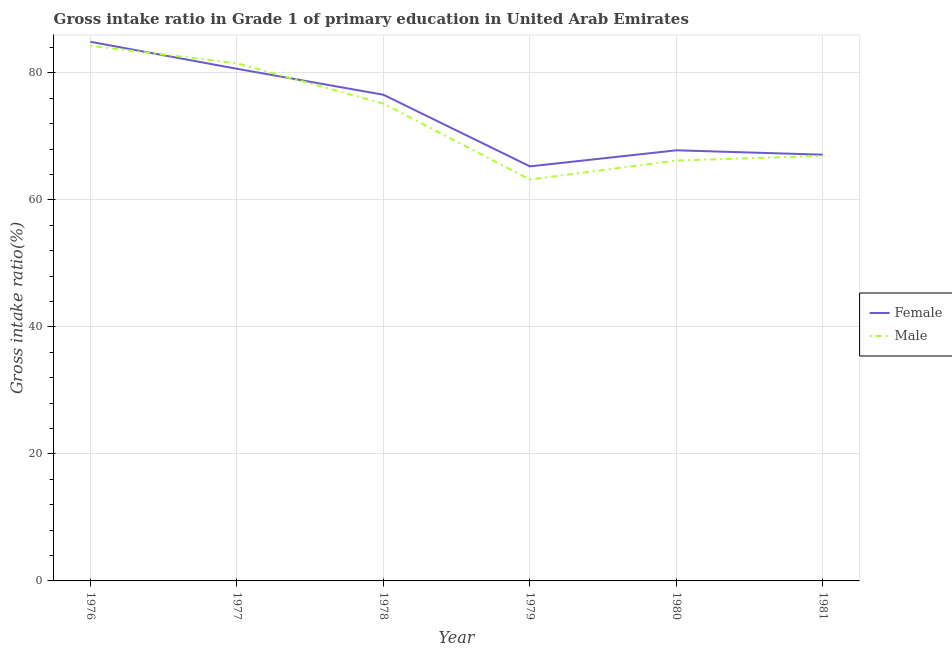How many different coloured lines are there?
Offer a very short reply. 2. Does the line corresponding to gross intake ratio(male) intersect with the line corresponding to gross intake ratio(female)?
Your answer should be compact. Yes. What is the gross intake ratio(female) in 1977?
Your response must be concise. 80.64. Across all years, what is the maximum gross intake ratio(female)?
Ensure brevity in your answer.  84.89. Across all years, what is the minimum gross intake ratio(male)?
Ensure brevity in your answer.  63.2. In which year was the gross intake ratio(female) maximum?
Keep it short and to the point. 1976. In which year was the gross intake ratio(male) minimum?
Your answer should be very brief. 1979. What is the total gross intake ratio(female) in the graph?
Your response must be concise. 442.26. What is the difference between the gross intake ratio(female) in 1979 and that in 1981?
Make the answer very short. -1.84. What is the difference between the gross intake ratio(female) in 1978 and the gross intake ratio(male) in 1977?
Make the answer very short. -4.95. What is the average gross intake ratio(male) per year?
Provide a short and direct response. 72.87. In the year 1976, what is the difference between the gross intake ratio(female) and gross intake ratio(male)?
Your answer should be very brief. 0.64. What is the ratio of the gross intake ratio(female) in 1980 to that in 1981?
Your response must be concise. 1.01. Is the difference between the gross intake ratio(male) in 1980 and 1981 greater than the difference between the gross intake ratio(female) in 1980 and 1981?
Make the answer very short. No. What is the difference between the highest and the second highest gross intake ratio(male)?
Your response must be concise. 2.74. What is the difference between the highest and the lowest gross intake ratio(female)?
Your response must be concise. 19.62. In how many years, is the gross intake ratio(male) greater than the average gross intake ratio(male) taken over all years?
Your answer should be very brief. 3. Is the sum of the gross intake ratio(female) in 1976 and 1980 greater than the maximum gross intake ratio(male) across all years?
Your response must be concise. Yes. Does the gross intake ratio(male) monotonically increase over the years?
Make the answer very short. No. How many years are there in the graph?
Give a very brief answer. 6. What is the difference between two consecutive major ticks on the Y-axis?
Offer a terse response. 20. Are the values on the major ticks of Y-axis written in scientific E-notation?
Provide a succinct answer. No. Does the graph contain any zero values?
Provide a short and direct response. No. Where does the legend appear in the graph?
Your answer should be compact. Center right. How are the legend labels stacked?
Provide a short and direct response. Vertical. What is the title of the graph?
Your answer should be very brief. Gross intake ratio in Grade 1 of primary education in United Arab Emirates. Does "Study and work" appear as one of the legend labels in the graph?
Your answer should be compact. No. What is the label or title of the X-axis?
Keep it short and to the point. Year. What is the label or title of the Y-axis?
Offer a terse response. Gross intake ratio(%). What is the Gross intake ratio(%) of Female in 1976?
Provide a succinct answer. 84.89. What is the Gross intake ratio(%) of Male in 1976?
Offer a terse response. 84.25. What is the Gross intake ratio(%) in Female in 1977?
Provide a short and direct response. 80.64. What is the Gross intake ratio(%) of Male in 1977?
Keep it short and to the point. 81.51. What is the Gross intake ratio(%) of Female in 1978?
Ensure brevity in your answer.  76.55. What is the Gross intake ratio(%) in Male in 1978?
Provide a short and direct response. 75.15. What is the Gross intake ratio(%) in Female in 1979?
Offer a terse response. 65.27. What is the Gross intake ratio(%) of Male in 1979?
Give a very brief answer. 63.2. What is the Gross intake ratio(%) of Female in 1980?
Make the answer very short. 67.8. What is the Gross intake ratio(%) in Male in 1980?
Offer a terse response. 66.19. What is the Gross intake ratio(%) in Female in 1981?
Offer a terse response. 67.11. What is the Gross intake ratio(%) of Male in 1981?
Offer a terse response. 66.92. Across all years, what is the maximum Gross intake ratio(%) in Female?
Your answer should be very brief. 84.89. Across all years, what is the maximum Gross intake ratio(%) in Male?
Offer a very short reply. 84.25. Across all years, what is the minimum Gross intake ratio(%) of Female?
Keep it short and to the point. 65.27. Across all years, what is the minimum Gross intake ratio(%) of Male?
Provide a short and direct response. 63.2. What is the total Gross intake ratio(%) of Female in the graph?
Ensure brevity in your answer.  442.26. What is the total Gross intake ratio(%) of Male in the graph?
Offer a terse response. 437.22. What is the difference between the Gross intake ratio(%) of Female in 1976 and that in 1977?
Your answer should be compact. 4.25. What is the difference between the Gross intake ratio(%) of Male in 1976 and that in 1977?
Keep it short and to the point. 2.74. What is the difference between the Gross intake ratio(%) of Female in 1976 and that in 1978?
Offer a terse response. 8.34. What is the difference between the Gross intake ratio(%) of Male in 1976 and that in 1978?
Provide a succinct answer. 9.1. What is the difference between the Gross intake ratio(%) of Female in 1976 and that in 1979?
Your answer should be compact. 19.62. What is the difference between the Gross intake ratio(%) in Male in 1976 and that in 1979?
Keep it short and to the point. 21.05. What is the difference between the Gross intake ratio(%) in Female in 1976 and that in 1980?
Make the answer very short. 17.09. What is the difference between the Gross intake ratio(%) in Male in 1976 and that in 1980?
Make the answer very short. 18.06. What is the difference between the Gross intake ratio(%) in Female in 1976 and that in 1981?
Ensure brevity in your answer.  17.78. What is the difference between the Gross intake ratio(%) of Male in 1976 and that in 1981?
Give a very brief answer. 17.33. What is the difference between the Gross intake ratio(%) of Female in 1977 and that in 1978?
Keep it short and to the point. 4.09. What is the difference between the Gross intake ratio(%) in Male in 1977 and that in 1978?
Give a very brief answer. 6.35. What is the difference between the Gross intake ratio(%) in Female in 1977 and that in 1979?
Ensure brevity in your answer.  15.37. What is the difference between the Gross intake ratio(%) in Male in 1977 and that in 1979?
Provide a short and direct response. 18.31. What is the difference between the Gross intake ratio(%) in Female in 1977 and that in 1980?
Offer a very short reply. 12.84. What is the difference between the Gross intake ratio(%) in Male in 1977 and that in 1980?
Ensure brevity in your answer.  15.32. What is the difference between the Gross intake ratio(%) of Female in 1977 and that in 1981?
Provide a short and direct response. 13.53. What is the difference between the Gross intake ratio(%) in Male in 1977 and that in 1981?
Provide a short and direct response. 14.58. What is the difference between the Gross intake ratio(%) of Female in 1978 and that in 1979?
Your answer should be very brief. 11.28. What is the difference between the Gross intake ratio(%) of Male in 1978 and that in 1979?
Your answer should be very brief. 11.95. What is the difference between the Gross intake ratio(%) in Female in 1978 and that in 1980?
Offer a terse response. 8.75. What is the difference between the Gross intake ratio(%) of Male in 1978 and that in 1980?
Keep it short and to the point. 8.96. What is the difference between the Gross intake ratio(%) in Female in 1978 and that in 1981?
Your answer should be compact. 9.44. What is the difference between the Gross intake ratio(%) of Male in 1978 and that in 1981?
Your answer should be compact. 8.23. What is the difference between the Gross intake ratio(%) in Female in 1979 and that in 1980?
Provide a short and direct response. -2.53. What is the difference between the Gross intake ratio(%) in Male in 1979 and that in 1980?
Your answer should be compact. -2.99. What is the difference between the Gross intake ratio(%) in Female in 1979 and that in 1981?
Your response must be concise. -1.84. What is the difference between the Gross intake ratio(%) of Male in 1979 and that in 1981?
Provide a short and direct response. -3.72. What is the difference between the Gross intake ratio(%) in Female in 1980 and that in 1981?
Your answer should be compact. 0.69. What is the difference between the Gross intake ratio(%) in Male in 1980 and that in 1981?
Your response must be concise. -0.73. What is the difference between the Gross intake ratio(%) in Female in 1976 and the Gross intake ratio(%) in Male in 1977?
Keep it short and to the point. 3.39. What is the difference between the Gross intake ratio(%) of Female in 1976 and the Gross intake ratio(%) of Male in 1978?
Your answer should be very brief. 9.74. What is the difference between the Gross intake ratio(%) of Female in 1976 and the Gross intake ratio(%) of Male in 1979?
Make the answer very short. 21.69. What is the difference between the Gross intake ratio(%) in Female in 1976 and the Gross intake ratio(%) in Male in 1980?
Give a very brief answer. 18.7. What is the difference between the Gross intake ratio(%) of Female in 1976 and the Gross intake ratio(%) of Male in 1981?
Give a very brief answer. 17.97. What is the difference between the Gross intake ratio(%) in Female in 1977 and the Gross intake ratio(%) in Male in 1978?
Your response must be concise. 5.48. What is the difference between the Gross intake ratio(%) in Female in 1977 and the Gross intake ratio(%) in Male in 1979?
Provide a short and direct response. 17.44. What is the difference between the Gross intake ratio(%) in Female in 1977 and the Gross intake ratio(%) in Male in 1980?
Keep it short and to the point. 14.45. What is the difference between the Gross intake ratio(%) of Female in 1977 and the Gross intake ratio(%) of Male in 1981?
Give a very brief answer. 13.71. What is the difference between the Gross intake ratio(%) of Female in 1978 and the Gross intake ratio(%) of Male in 1979?
Your response must be concise. 13.35. What is the difference between the Gross intake ratio(%) of Female in 1978 and the Gross intake ratio(%) of Male in 1980?
Provide a short and direct response. 10.36. What is the difference between the Gross intake ratio(%) of Female in 1978 and the Gross intake ratio(%) of Male in 1981?
Offer a very short reply. 9.63. What is the difference between the Gross intake ratio(%) in Female in 1979 and the Gross intake ratio(%) in Male in 1980?
Keep it short and to the point. -0.92. What is the difference between the Gross intake ratio(%) in Female in 1979 and the Gross intake ratio(%) in Male in 1981?
Keep it short and to the point. -1.65. What is the difference between the Gross intake ratio(%) in Female in 1980 and the Gross intake ratio(%) in Male in 1981?
Offer a very short reply. 0.88. What is the average Gross intake ratio(%) of Female per year?
Ensure brevity in your answer.  73.71. What is the average Gross intake ratio(%) of Male per year?
Give a very brief answer. 72.87. In the year 1976, what is the difference between the Gross intake ratio(%) in Female and Gross intake ratio(%) in Male?
Your answer should be very brief. 0.64. In the year 1977, what is the difference between the Gross intake ratio(%) of Female and Gross intake ratio(%) of Male?
Offer a terse response. -0.87. In the year 1978, what is the difference between the Gross intake ratio(%) in Female and Gross intake ratio(%) in Male?
Offer a terse response. 1.4. In the year 1979, what is the difference between the Gross intake ratio(%) in Female and Gross intake ratio(%) in Male?
Your answer should be very brief. 2.07. In the year 1980, what is the difference between the Gross intake ratio(%) of Female and Gross intake ratio(%) of Male?
Give a very brief answer. 1.61. In the year 1981, what is the difference between the Gross intake ratio(%) of Female and Gross intake ratio(%) of Male?
Ensure brevity in your answer.  0.19. What is the ratio of the Gross intake ratio(%) of Female in 1976 to that in 1977?
Offer a terse response. 1.05. What is the ratio of the Gross intake ratio(%) of Male in 1976 to that in 1977?
Ensure brevity in your answer.  1.03. What is the ratio of the Gross intake ratio(%) of Female in 1976 to that in 1978?
Give a very brief answer. 1.11. What is the ratio of the Gross intake ratio(%) of Male in 1976 to that in 1978?
Give a very brief answer. 1.12. What is the ratio of the Gross intake ratio(%) of Female in 1976 to that in 1979?
Your answer should be compact. 1.3. What is the ratio of the Gross intake ratio(%) in Male in 1976 to that in 1979?
Your answer should be compact. 1.33. What is the ratio of the Gross intake ratio(%) in Female in 1976 to that in 1980?
Your answer should be compact. 1.25. What is the ratio of the Gross intake ratio(%) in Male in 1976 to that in 1980?
Offer a very short reply. 1.27. What is the ratio of the Gross intake ratio(%) in Female in 1976 to that in 1981?
Give a very brief answer. 1.26. What is the ratio of the Gross intake ratio(%) in Male in 1976 to that in 1981?
Offer a terse response. 1.26. What is the ratio of the Gross intake ratio(%) in Female in 1977 to that in 1978?
Your answer should be very brief. 1.05. What is the ratio of the Gross intake ratio(%) of Male in 1977 to that in 1978?
Give a very brief answer. 1.08. What is the ratio of the Gross intake ratio(%) of Female in 1977 to that in 1979?
Keep it short and to the point. 1.24. What is the ratio of the Gross intake ratio(%) in Male in 1977 to that in 1979?
Your response must be concise. 1.29. What is the ratio of the Gross intake ratio(%) of Female in 1977 to that in 1980?
Give a very brief answer. 1.19. What is the ratio of the Gross intake ratio(%) in Male in 1977 to that in 1980?
Your answer should be very brief. 1.23. What is the ratio of the Gross intake ratio(%) in Female in 1977 to that in 1981?
Your answer should be very brief. 1.2. What is the ratio of the Gross intake ratio(%) of Male in 1977 to that in 1981?
Your response must be concise. 1.22. What is the ratio of the Gross intake ratio(%) in Female in 1978 to that in 1979?
Make the answer very short. 1.17. What is the ratio of the Gross intake ratio(%) of Male in 1978 to that in 1979?
Provide a short and direct response. 1.19. What is the ratio of the Gross intake ratio(%) of Female in 1978 to that in 1980?
Provide a short and direct response. 1.13. What is the ratio of the Gross intake ratio(%) in Male in 1978 to that in 1980?
Keep it short and to the point. 1.14. What is the ratio of the Gross intake ratio(%) of Female in 1978 to that in 1981?
Your response must be concise. 1.14. What is the ratio of the Gross intake ratio(%) in Male in 1978 to that in 1981?
Your response must be concise. 1.12. What is the ratio of the Gross intake ratio(%) in Female in 1979 to that in 1980?
Give a very brief answer. 0.96. What is the ratio of the Gross intake ratio(%) in Male in 1979 to that in 1980?
Make the answer very short. 0.95. What is the ratio of the Gross intake ratio(%) in Female in 1979 to that in 1981?
Offer a terse response. 0.97. What is the ratio of the Gross intake ratio(%) of Female in 1980 to that in 1981?
Keep it short and to the point. 1.01. What is the difference between the highest and the second highest Gross intake ratio(%) of Female?
Offer a very short reply. 4.25. What is the difference between the highest and the second highest Gross intake ratio(%) of Male?
Provide a short and direct response. 2.74. What is the difference between the highest and the lowest Gross intake ratio(%) in Female?
Provide a short and direct response. 19.62. What is the difference between the highest and the lowest Gross intake ratio(%) of Male?
Keep it short and to the point. 21.05. 